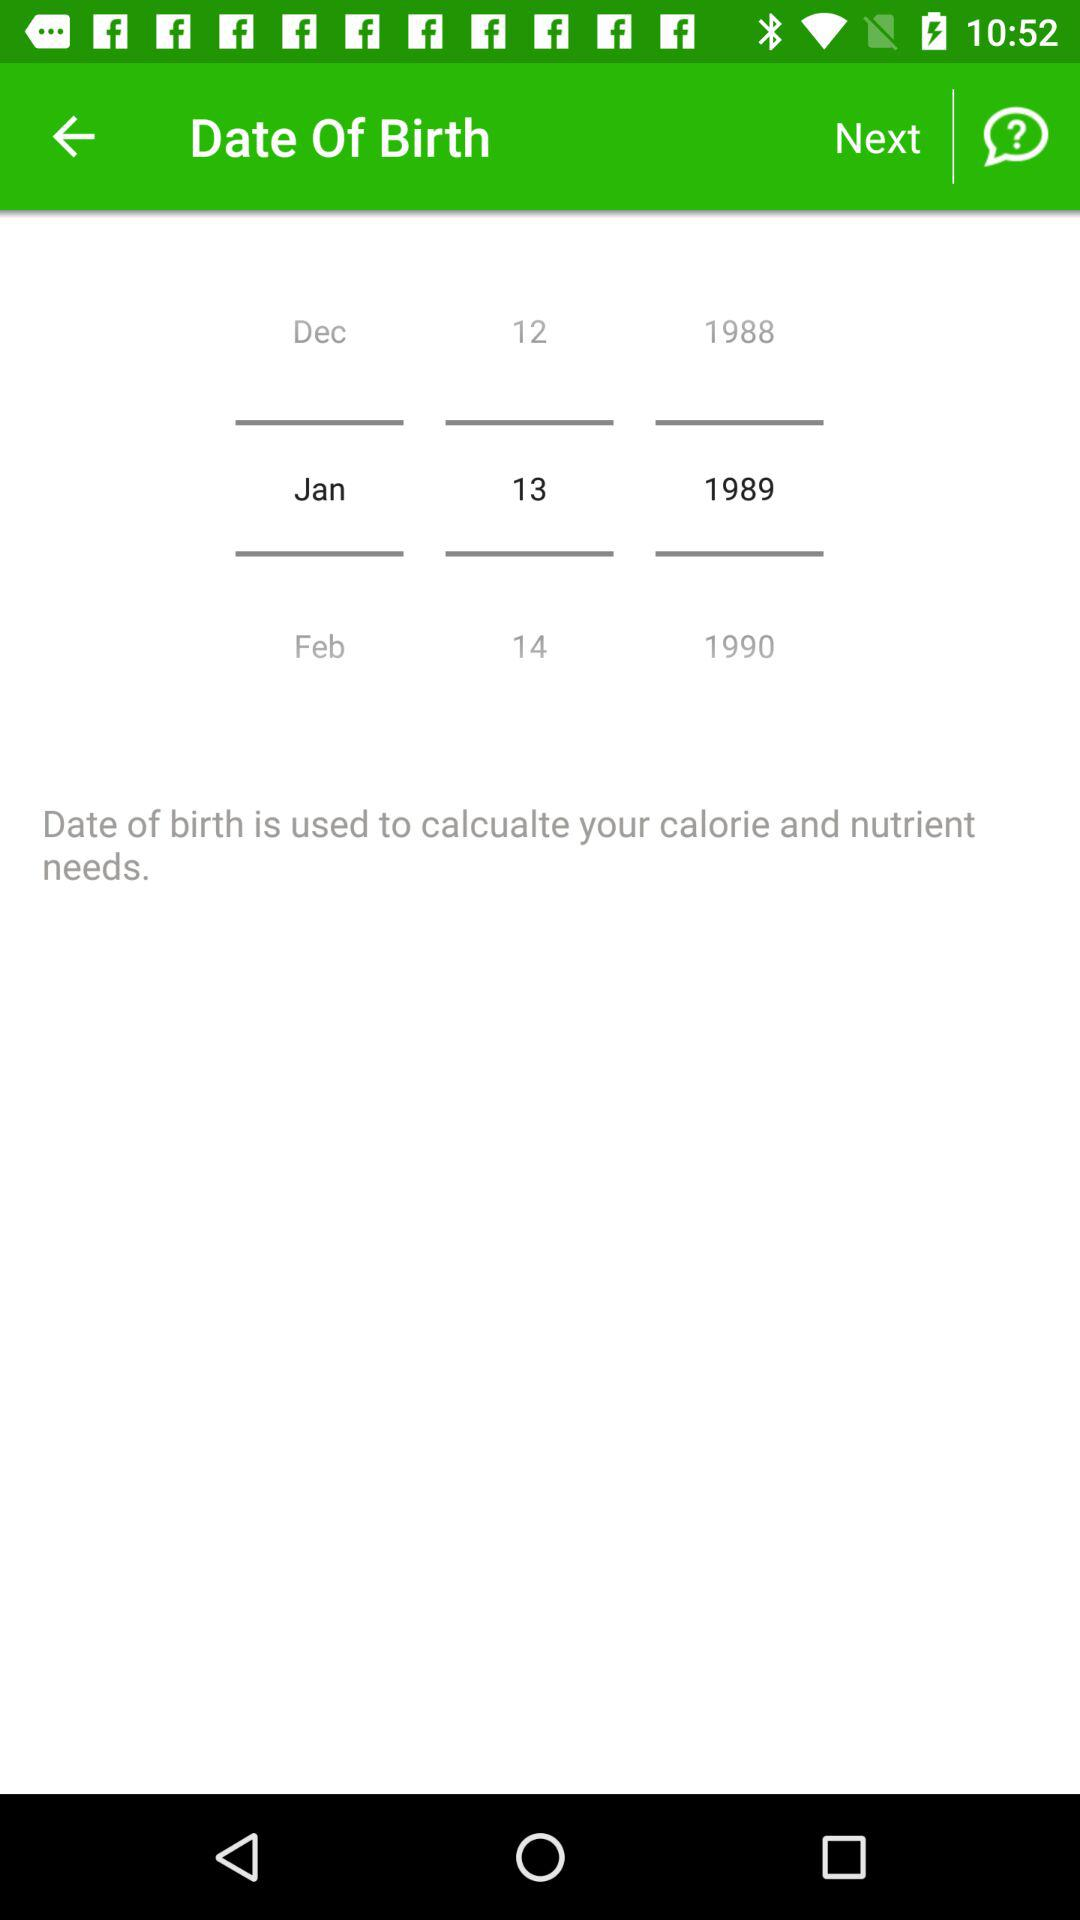How many years are there between the first and last date options?
Answer the question using a single word or phrase. 2 